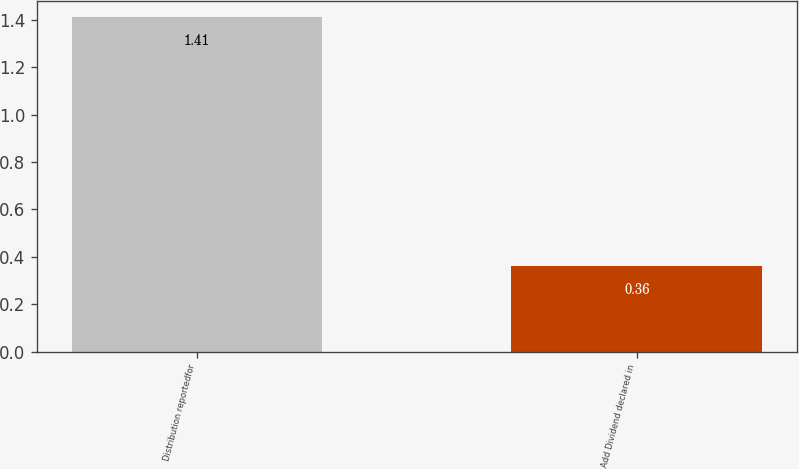Convert chart to OTSL. <chart><loc_0><loc_0><loc_500><loc_500><bar_chart><fcel>Distribution reportedfor<fcel>Add Dividend declared in<nl><fcel>1.41<fcel>0.36<nl></chart> 